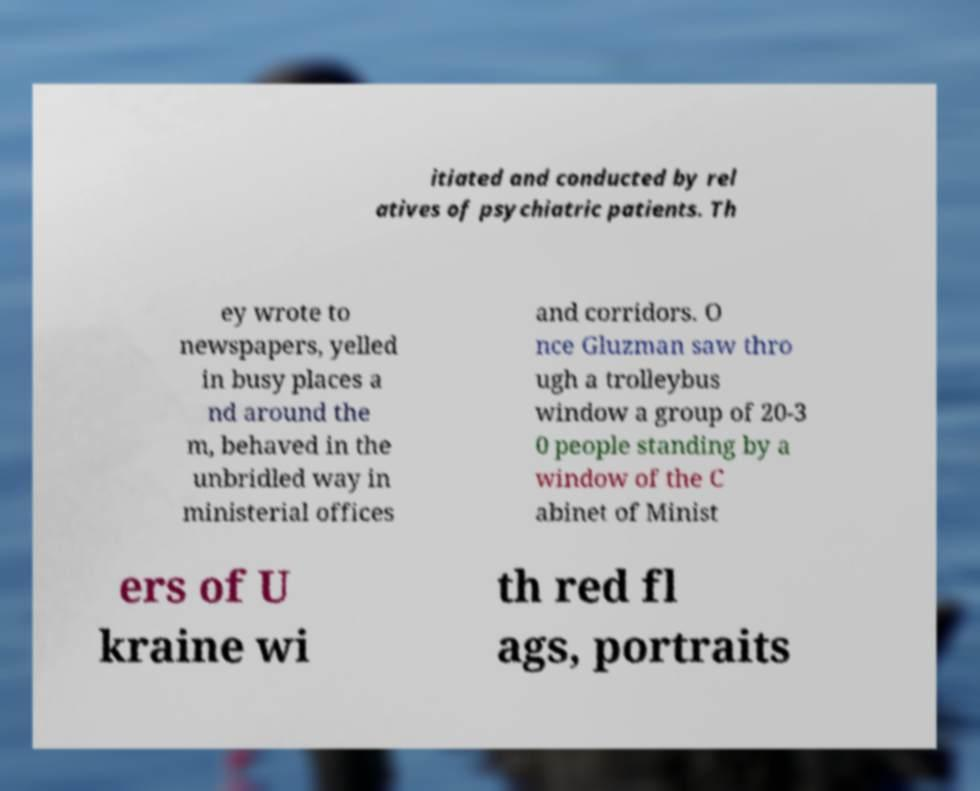What messages or text are displayed in this image? I need them in a readable, typed format. itiated and conducted by rel atives of psychiatric patients. Th ey wrote to newspapers, yelled in busy places a nd around the m, behaved in the unbridled way in ministerial offices and corridors. O nce Gluzman saw thro ugh a trolleybus window a group of 20-3 0 people standing by a window of the C abinet of Minist ers of U kraine wi th red fl ags, portraits 